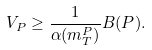Convert formula to latex. <formula><loc_0><loc_0><loc_500><loc_500>V _ { P } \geq \frac { 1 } { \alpha ( m _ { T } ^ { P } ) } B ( P ) .</formula> 